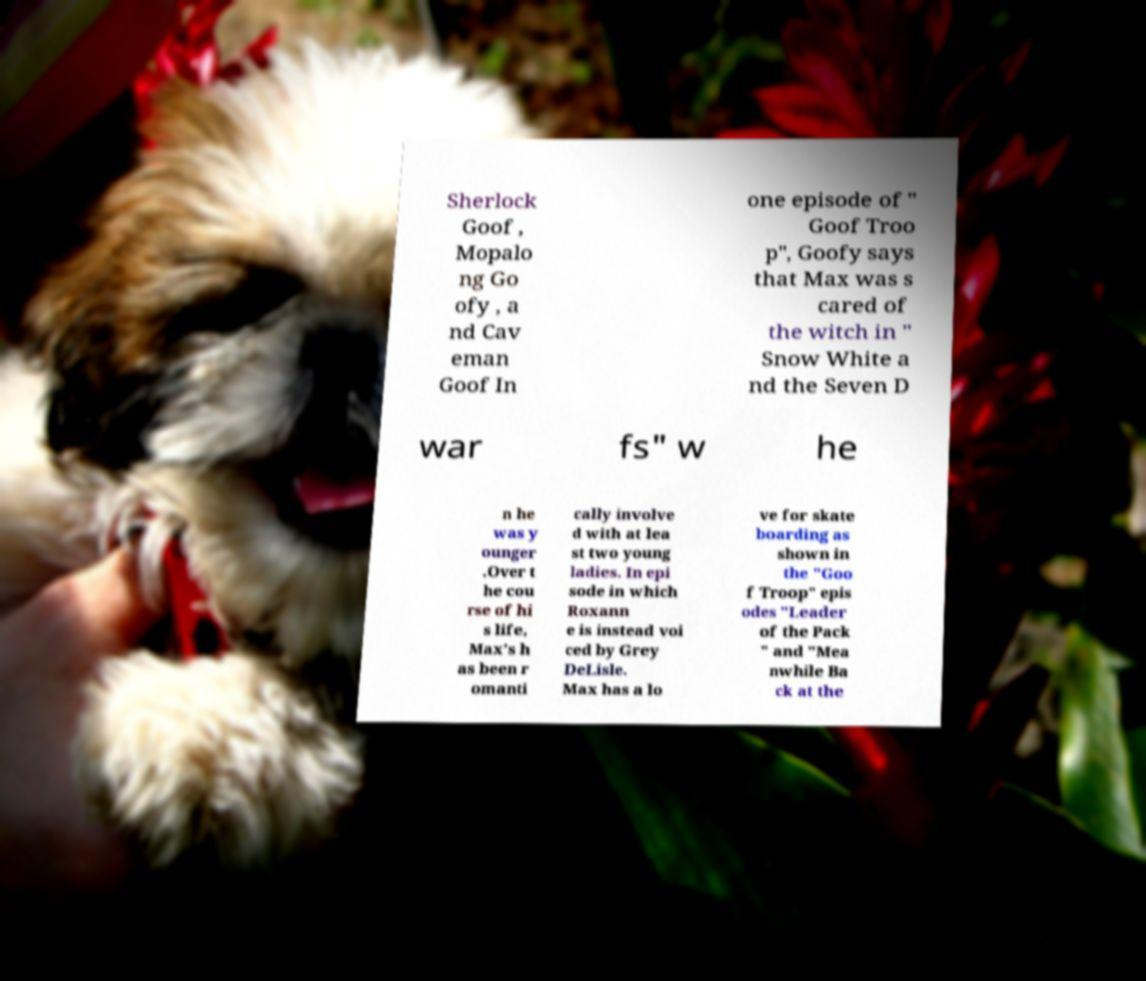Please identify and transcribe the text found in this image. Sherlock Goof , Mopalo ng Go ofy , a nd Cav eman Goof In one episode of " Goof Troo p", Goofy says that Max was s cared of the witch in " Snow White a nd the Seven D war fs" w he n he was y ounger .Over t he cou rse of hi s life, Max's h as been r omanti cally involve d with at lea st two young ladies. In epi sode in which Roxann e is instead voi ced by Grey DeLisle. Max has a lo ve for skate boarding as shown in the "Goo f Troop" epis odes "Leader of the Pack " and "Mea nwhile Ba ck at the 